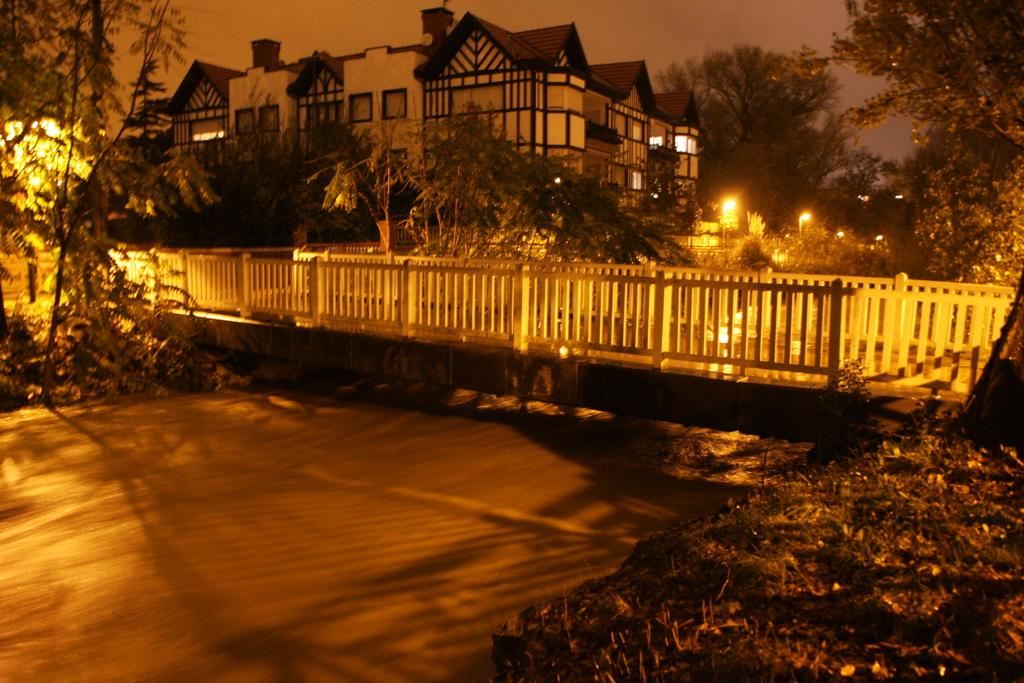What type of structure is present in the image? There is a bridge with railings in the image. What can be seen in the image besides the bridge? There are trees and a building in the background of the image. Are there any lighting features in the image? Yes, there are lights visible in the image. What riddle is being solved by the bridge in the image? There is no riddle being solved by the bridge in the image; it is simply a structure for crossing over a body of water or land. 